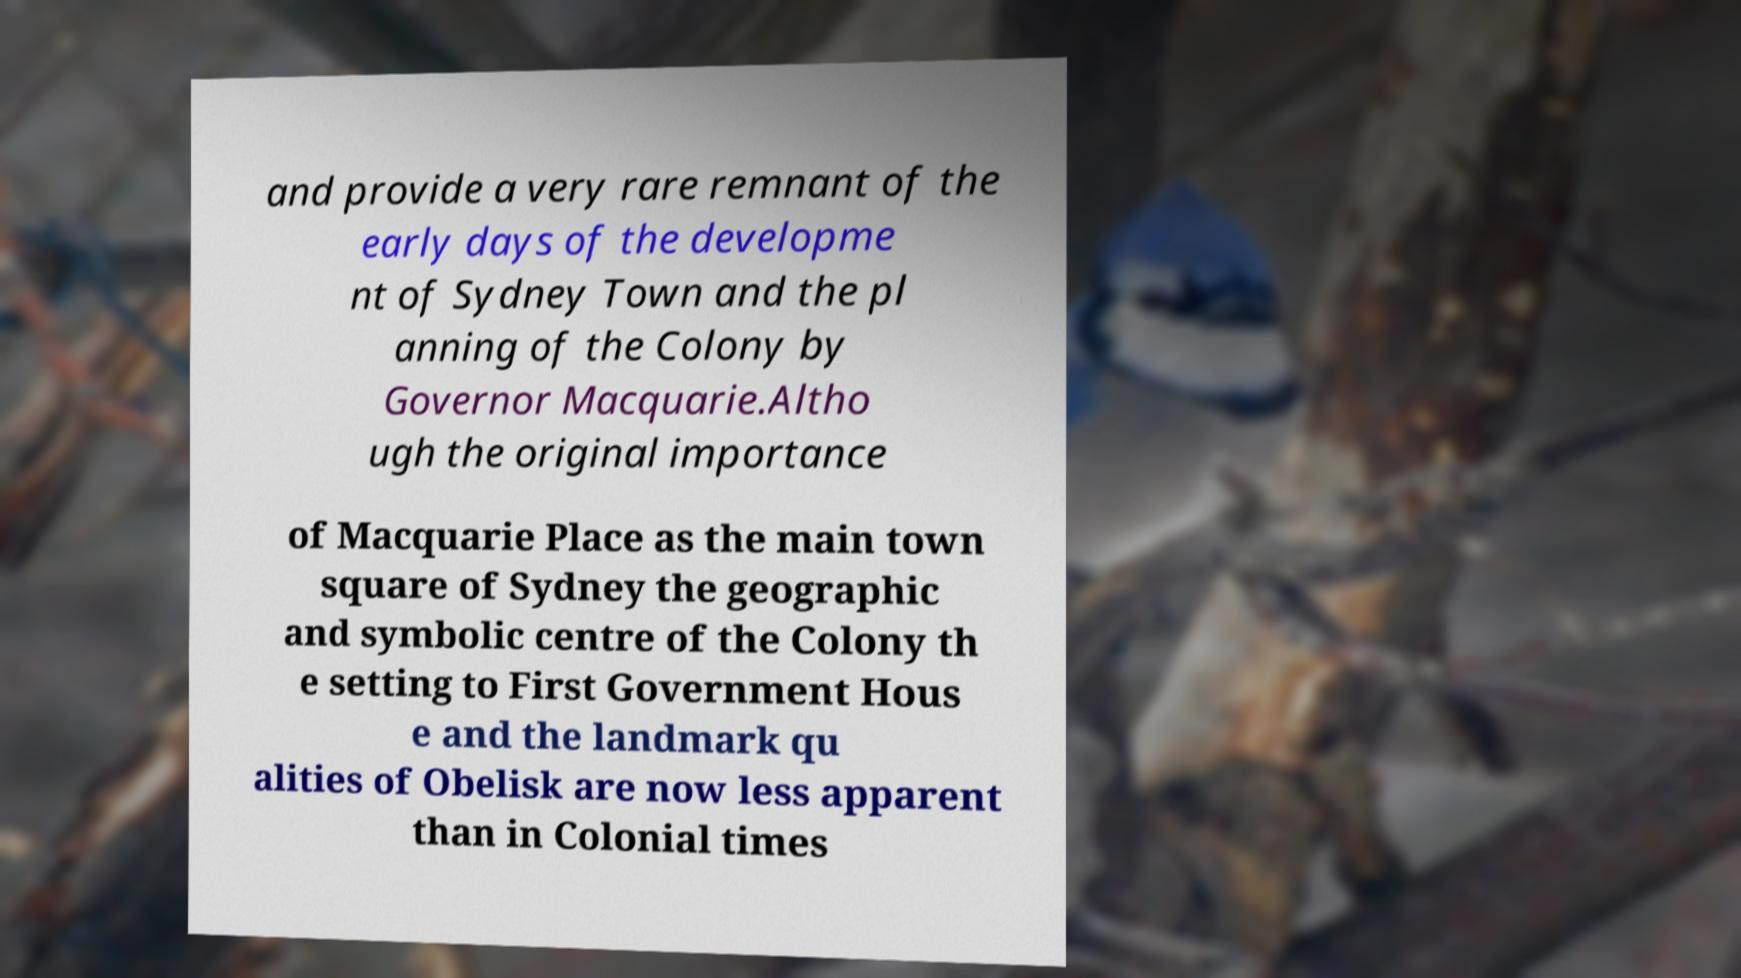For documentation purposes, I need the text within this image transcribed. Could you provide that? and provide a very rare remnant of the early days of the developme nt of Sydney Town and the pl anning of the Colony by Governor Macquarie.Altho ugh the original importance of Macquarie Place as the main town square of Sydney the geographic and symbolic centre of the Colony th e setting to First Government Hous e and the landmark qu alities of Obelisk are now less apparent than in Colonial times 